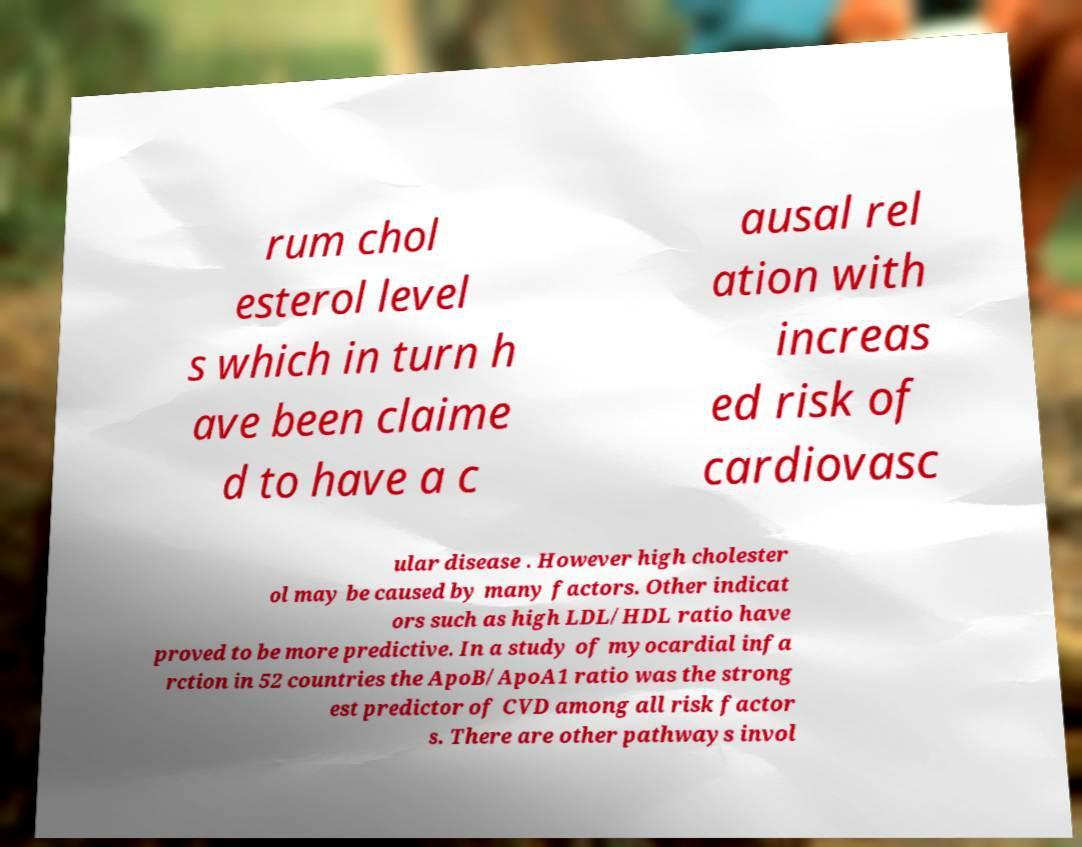Can you accurately transcribe the text from the provided image for me? rum chol esterol level s which in turn h ave been claime d to have a c ausal rel ation with increas ed risk of cardiovasc ular disease . However high cholester ol may be caused by many factors. Other indicat ors such as high LDL/HDL ratio have proved to be more predictive. In a study of myocardial infa rction in 52 countries the ApoB/ApoA1 ratio was the strong est predictor of CVD among all risk factor s. There are other pathways invol 